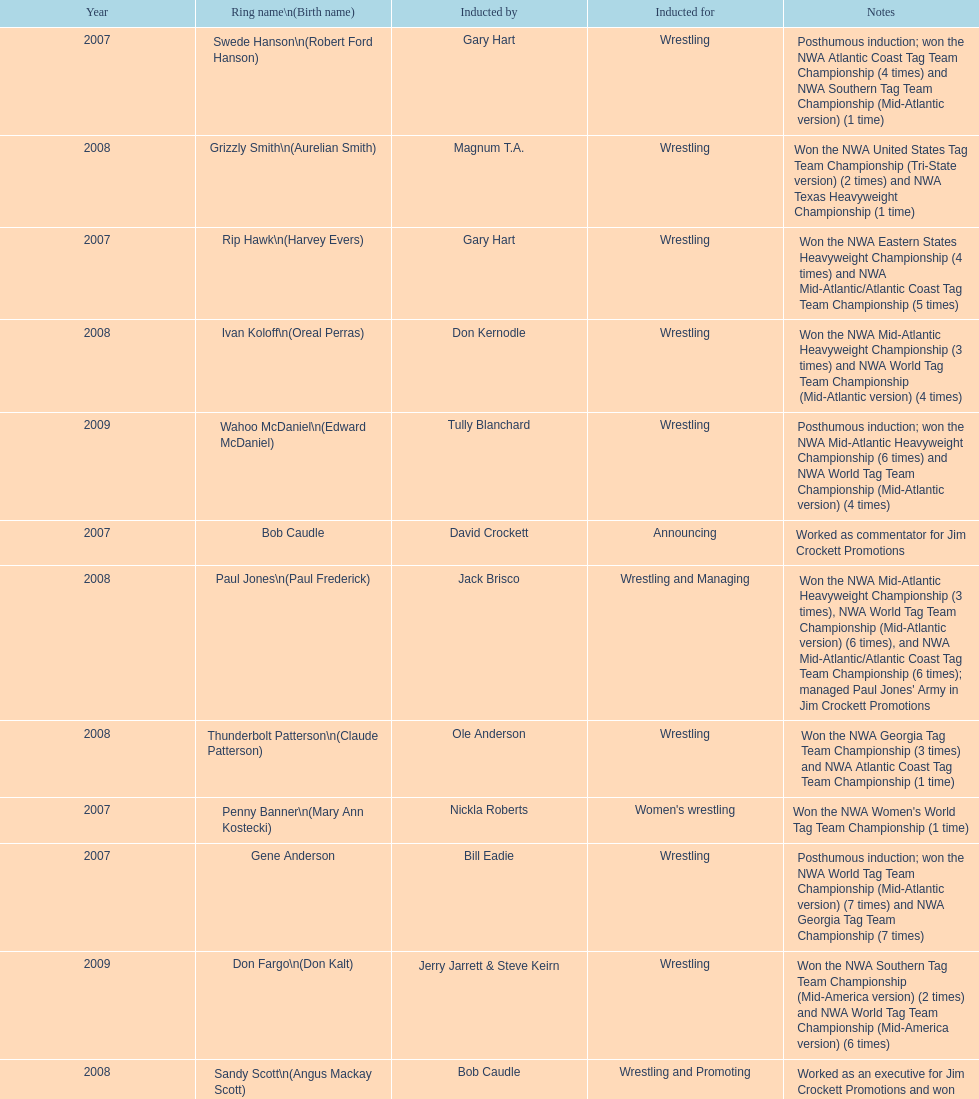Inform me about an inductee who was deceased at the moment. Gene Anderson. 